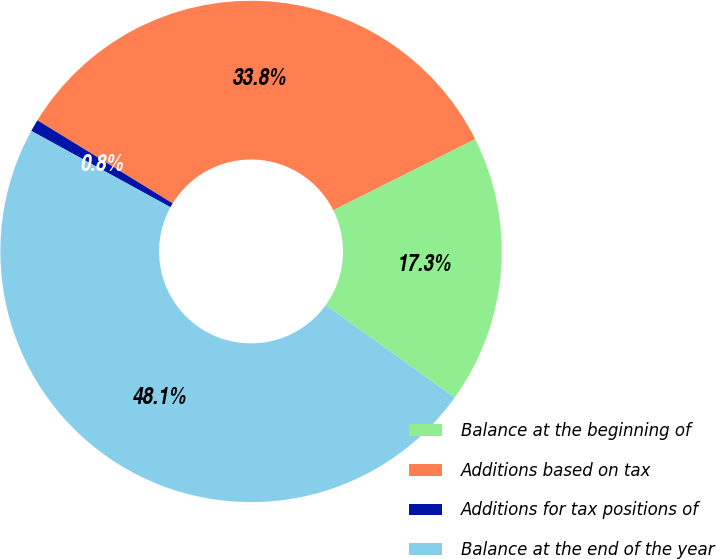Convert chart. <chart><loc_0><loc_0><loc_500><loc_500><pie_chart><fcel>Balance at the beginning of<fcel>Additions based on tax<fcel>Additions for tax positions of<fcel>Balance at the end of the year<nl><fcel>17.31%<fcel>33.84%<fcel>0.78%<fcel>48.08%<nl></chart> 